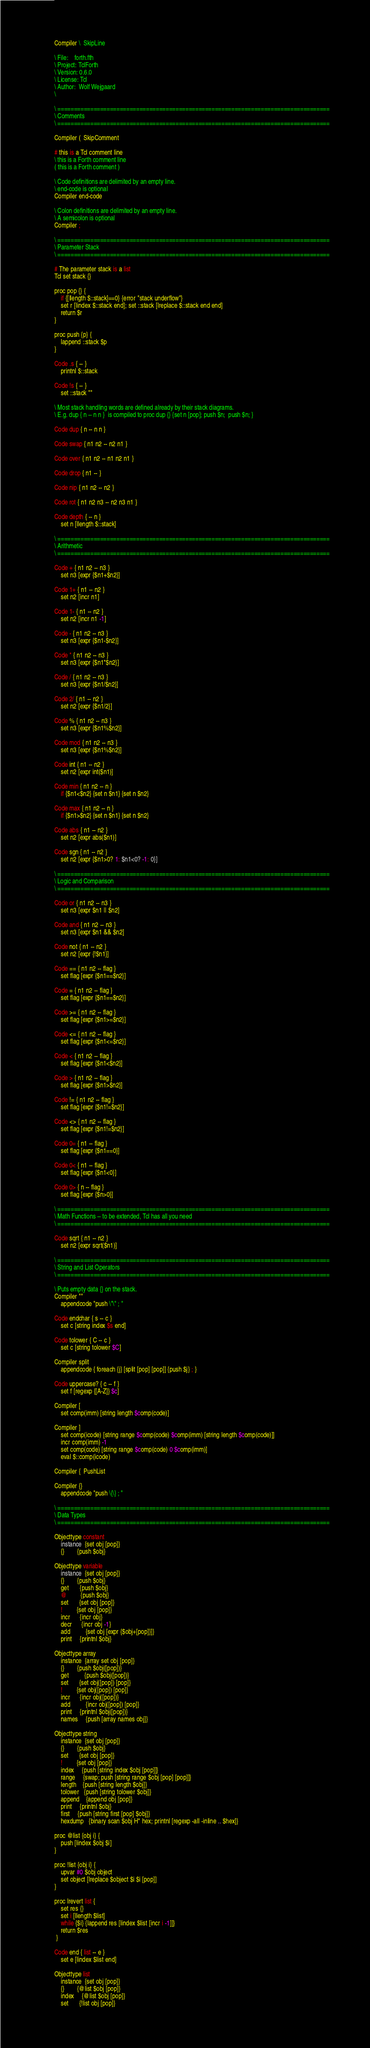Convert code to text. <code><loc_0><loc_0><loc_500><loc_500><_Forth_>Compiler \  SkipLine

\ File:    forth.fth
\ Project: TclForth
\ Version: 0.6.0
\ License: Tcl
\ Author:  Wolf Wejgaard
\ 

\ ===================================================================================
\ Comments
\ ===================================================================================

Compiler (  SkipComment

# this is a Tcl comment line 
\ this is a Forth comment line
( this is a Forth comment )

\ Code definitions are delimited by an empty line.
\ end-code is optional
Compiler end-code

\ Colon definitions are delimited by an empty line.
\ A semicolon is optional
Compiler ;

\ ===================================================================================
\ Parameter Stack
\ ===================================================================================

# The parameter stack is a list
Tcl set stack {}

proc pop {} {
	if {[llength $::stack]==0} {error "stack underflow"}
	set r [lindex $::stack end]; set ::stack [lreplace $::stack end end]
	return $r 
}

proc push {p} {
	lappend ::stack $p
}

Code .s { -- }  
	printnl $::stack

Code !s { -- }  
	set ::stack ""

\ Most stack handling words are defined already by their stack diagrams.
\ E.g. dup { n -- n n }  is compiled to proc dup {} {set n [pop]; push $n;  push $n; }

Code dup { n -- n n }

Code swap { n1 n2 -- n2 n1 }

Code over { n1 n2 -- n1 n2 n1 }

Code drop { n1 -- }

Code nip { n1 n2 -- n2 }

Code rot { n1 n2 n3 -- n2 n3 n1 }

Code depth { -- n }
	set n [llength $::stack]

\ ===================================================================================
\ Arithmetic
\ ===================================================================================

Code + { n1 n2 -- n3 } 
	set n3 [expr {$n1+$n2}]

Code 1+ { n1 -- n2 }
	set n2 [incr n1]

Code 1- { n1 -- n2 } 
	set n2 [incr n1 -1]

Code - { n1 n2 -- n3 }
	set n3 [expr {$n1-$n2}]

Code * { n1 n2 -- n3 } 
	set n3 [expr {$n1*$n2}]

Code / { n1 n2 -- n3 } 
	set n3 [expr {$n1/$n2}]

Code 2/ { n1 -- n2 }  
	set n2 [expr {$n1/2}]

Code % { n1 n2 -- n3 }  
	set n3 [expr {$n1%$n2}]

Code mod { n1 n2 -- n3 }  
	set n3 [expr {$n1%$n2}]

Code int { n1 -- n2 } 
	set n2 [expr int($n1)]

Code min { n1 n2 -- n } 
	if {$n1<$n2} {set n $n1} {set n $n2}

Code max { n1 n2 -- n } 
	if {$n1>$n2} {set n $n1} {set n $n2}

Code abs { n1 -- n2 }  
	set n2 [expr abs($n1)]

Code sgn { n1 -- n2 }  
	set n2 [expr {$n1>0? 1: $n1<0? -1: 0}]

\ ===================================================================================
\ Logic and Comparison
\ ===================================================================================

Code or { n1 n2 -- n3 }
	set n3 [expr $n1 || $n2]

Code and { n1 n2 -- n3 } 
	set n3 [expr $n1 && $n2]

Code not { n1 -- n2 }  
	set n2 [expr {!$n1}]

Code == { n1 n2 -- flag }  
	set flag [expr {$n1==$n2}]

Code = { n1 n2 -- flag }  
	set flag [expr {$n1==$n2}]

Code >= { n1 n2 -- flag }  
	set flag [expr {$n1>=$n2}]

Code <= { n1 n2 -- flag } 
	set flag [expr {$n1<=$n2}]

Code < { n1 n2 -- flag }  
	set flag [expr {$n1<$n2}]

Code > { n1 n2 -- flag }  
	set flag [expr {$n1>$n2}]

Code != { n1 n2 -- flag } 
	set flag [expr {$n1!=$n2}]

Code <> { n1 n2 -- flag }  
	set flag [expr {$n1!=$n2}]

Code 0= { n1 -- flag }  
	set flag [expr {$n1==0}]

Code 0< { n1 -- flag } 
	set flag [expr {$n1<0}]

Code 0> { n -- flag }
	set flag [expr {$n>0}]

\ ===================================================================================
\ Math Functions -- to be extended, Tcl has all you need
\ ===================================================================================

Code sqrt { n1 -- n2 } 
	set n2 [expr sqrt($n1)]

\ ===================================================================================
\ String and List Operators
\ ===================================================================================

\ Puts empty data {} on the stack. 
Compiler ""  
	appendcode "push \"\" ; "

Code endchar { s -- c }
	set c [string index $s end]

Code tolower { C -- c }  
	set c [string tolower $C]

Compiler split 
	appendcode { foreach {j} [split [pop] [pop]] {push $j} ; }

Code uppercase? { c -- f }  
	set f [regexp {[A-Z]} $c]

Compiler [
	set comp(imm) [string length $comp(code)]

Compiler ]
	set comp(icode) [string range $comp(code) $comp(imm) [string length $comp(code)]]
	incr comp(imm) -1
	set comp(code) [string range $comp(code) 0 $comp(imm)]
	eval $::comp(icode)

Compiler {  PushList

Compiler {} 
	appendcode "push \{\} ; "

\ ===================================================================================
\ Data Types  
\ ===================================================================================

Objecttype constant  
	instance  {set obj [pop]}
	{}        {push $obj}

Objecttype variable  
	instance  {set obj [pop]}
	{}        {push $obj}
	get       {push $obj}
	@         {push $obj}
	set       {set obj [pop]}
	!         {set obj [pop]}
	incr      {incr obj}
	decr      {incr obj -1}
	add	      {set obj [expr {$obj+[pop]}]}
	print     {printnl $obj}

Objecttype array   
	instance  {array set obj [pop]}
	{}        {push $obj([pop])}
	get	      {push $obj([pop])}
	set       {set obj([pop]) [pop]}
	!         {set obj([pop]) [pop]}
	incr      {incr obj([pop])}
	add	      {incr obj([pop]) [pop]}
	print     {printnl $obj([pop])}
	names     {push [array names obj]}

Objecttype string   
	instance  {set obj [pop]}
	{}        {push $obj}
	set       {set obj [pop]}
	!         {set obj [pop]}
	index     {push [string index $obj [pop]]}
	range     {swap; push [string range $obj [pop] [pop]]}
	length    {push [string length $obj]}
	tolower   {push [string tolower $obj]}
	append    {append obj [pop]}
	print     {printnl $obj}
	first     {push [string first [pop] $obj]}
	hexdump   {binary scan $obj H* hex; printnl [regexp -all -inline .. $hex]}

proc @list {obj i} {
	push [lindex $obj $i]
}

proc !list {obj i} {
	upvar #0 $obj object
	set object [lreplace $object $i $i [pop]]
}

proc lrevert list {
	set res {}
	set i [llength $list]
	while {$i} {lappend res [lindex $list [incr i -1]]}
	return $res
 }

Code end { list -- e }  
	set e [lindex $list end]

Objecttype list   
	instance  {set obj [pop]}
	{}        {@list $obj [pop]}  
	index     {@list $obj [pop]}
	set       {!list obj [pop]}  </code> 